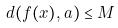Convert formula to latex. <formula><loc_0><loc_0><loc_500><loc_500>d ( f ( x ) , a ) \leq M</formula> 